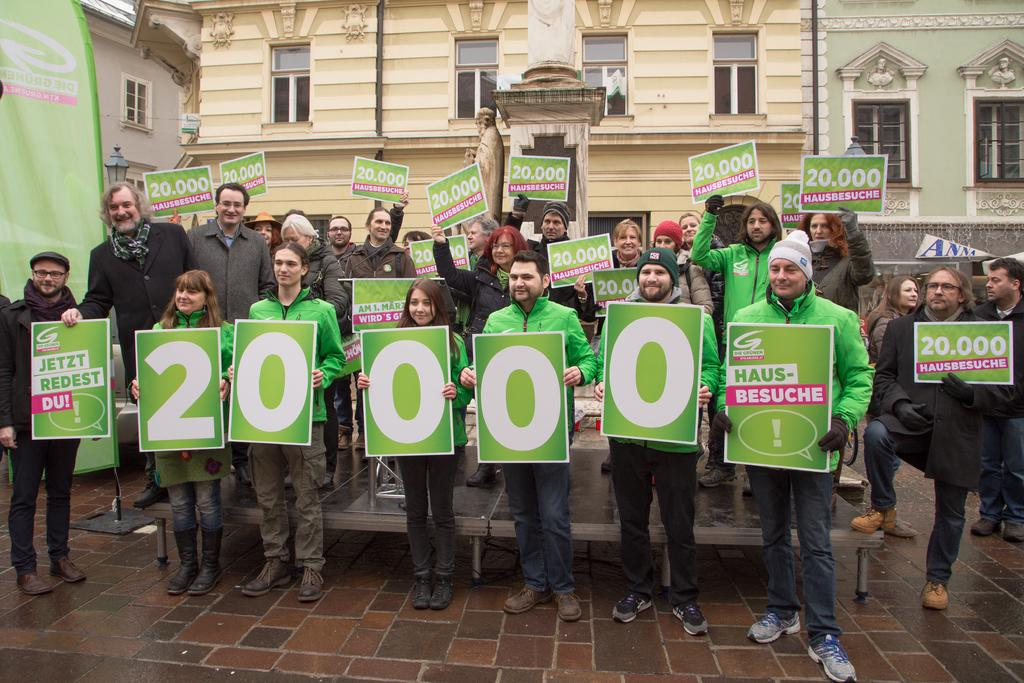What are the people in the image doing? The people in the image are standing and holding posters. What can be seen in the background of the image? There are buildings in the background of the image. What feature is present on the buildings? There are windows on the buildings. What type of bulb is used to illuminate the sign in the image? There is no sign present in the image, so it is not possible to determine what type of bulb might be used to illuminate it. 